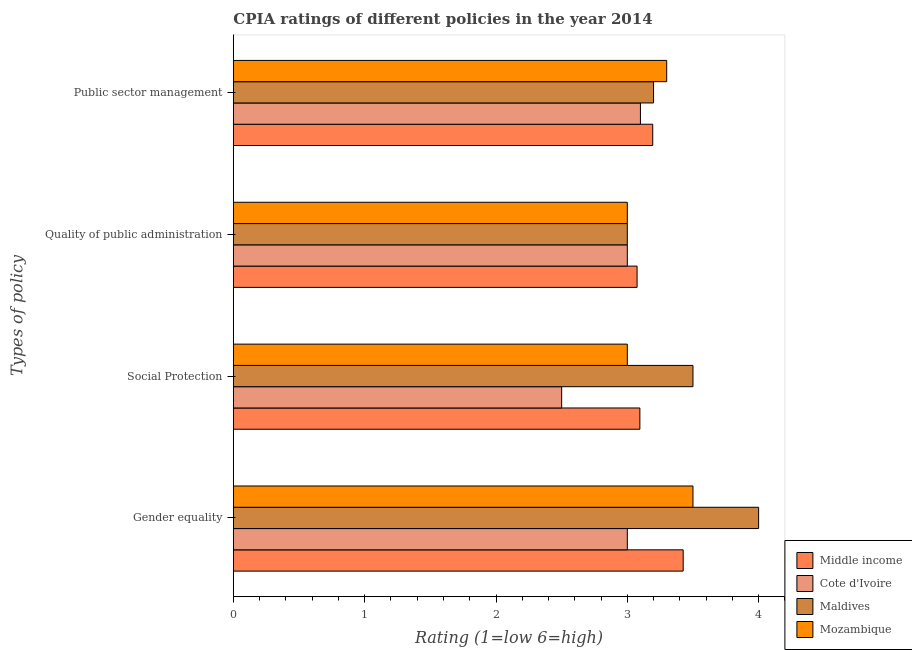How many different coloured bars are there?
Provide a succinct answer. 4. How many groups of bars are there?
Provide a succinct answer. 4. How many bars are there on the 1st tick from the top?
Your answer should be compact. 4. What is the label of the 3rd group of bars from the top?
Your answer should be compact. Social Protection. Across all countries, what is the minimum cpia rating of gender equality?
Keep it short and to the point. 3. In which country was the cpia rating of gender equality maximum?
Keep it short and to the point. Maldives. In which country was the cpia rating of social protection minimum?
Your response must be concise. Cote d'Ivoire. What is the total cpia rating of public sector management in the graph?
Offer a terse response. 12.79. What is the difference between the cpia rating of gender equality in Cote d'Ivoire and that in Maldives?
Your response must be concise. -1. What is the difference between the cpia rating of quality of public administration in Cote d'Ivoire and the cpia rating of public sector management in Maldives?
Offer a very short reply. -0.2. What is the average cpia rating of quality of public administration per country?
Offer a terse response. 3.02. What is the difference between the cpia rating of quality of public administration and cpia rating of social protection in Mozambique?
Your answer should be compact. 0. What is the ratio of the cpia rating of quality of public administration in Cote d'Ivoire to that in Middle income?
Provide a succinct answer. 0.98. What is the difference between the highest and the second highest cpia rating of quality of public administration?
Offer a very short reply. 0.07. What is the difference between the highest and the lowest cpia rating of social protection?
Keep it short and to the point. 1. What does the 2nd bar from the top in Public sector management represents?
Make the answer very short. Maldives. What does the 3rd bar from the bottom in Public sector management represents?
Your response must be concise. Maldives. How many countries are there in the graph?
Offer a terse response. 4. Does the graph contain grids?
Keep it short and to the point. No. What is the title of the graph?
Offer a terse response. CPIA ratings of different policies in the year 2014. Does "New Caledonia" appear as one of the legend labels in the graph?
Keep it short and to the point. No. What is the label or title of the X-axis?
Offer a very short reply. Rating (1=low 6=high). What is the label or title of the Y-axis?
Give a very brief answer. Types of policy. What is the Rating (1=low 6=high) in Middle income in Gender equality?
Provide a short and direct response. 3.43. What is the Rating (1=low 6=high) of Middle income in Social Protection?
Offer a terse response. 3.1. What is the Rating (1=low 6=high) of Maldives in Social Protection?
Your response must be concise. 3.5. What is the Rating (1=low 6=high) in Mozambique in Social Protection?
Give a very brief answer. 3. What is the Rating (1=low 6=high) in Middle income in Quality of public administration?
Make the answer very short. 3.07. What is the Rating (1=low 6=high) in Maldives in Quality of public administration?
Make the answer very short. 3. What is the Rating (1=low 6=high) of Mozambique in Quality of public administration?
Your response must be concise. 3. What is the Rating (1=low 6=high) in Middle income in Public sector management?
Ensure brevity in your answer.  3.19. What is the Rating (1=low 6=high) of Cote d'Ivoire in Public sector management?
Your answer should be compact. 3.1. What is the Rating (1=low 6=high) in Mozambique in Public sector management?
Make the answer very short. 3.3. Across all Types of policy, what is the maximum Rating (1=low 6=high) of Middle income?
Your answer should be compact. 3.43. Across all Types of policy, what is the maximum Rating (1=low 6=high) of Mozambique?
Offer a very short reply. 3.5. Across all Types of policy, what is the minimum Rating (1=low 6=high) of Middle income?
Ensure brevity in your answer.  3.07. Across all Types of policy, what is the minimum Rating (1=low 6=high) of Maldives?
Offer a terse response. 3. What is the total Rating (1=low 6=high) of Middle income in the graph?
Make the answer very short. 12.79. What is the total Rating (1=low 6=high) of Mozambique in the graph?
Provide a short and direct response. 12.8. What is the difference between the Rating (1=low 6=high) of Middle income in Gender equality and that in Social Protection?
Offer a terse response. 0.33. What is the difference between the Rating (1=low 6=high) of Cote d'Ivoire in Gender equality and that in Social Protection?
Provide a succinct answer. 0.5. What is the difference between the Rating (1=low 6=high) in Mozambique in Gender equality and that in Social Protection?
Your response must be concise. 0.5. What is the difference between the Rating (1=low 6=high) of Middle income in Gender equality and that in Quality of public administration?
Give a very brief answer. 0.35. What is the difference between the Rating (1=low 6=high) in Maldives in Gender equality and that in Quality of public administration?
Make the answer very short. 1. What is the difference between the Rating (1=low 6=high) in Middle income in Gender equality and that in Public sector management?
Offer a terse response. 0.23. What is the difference between the Rating (1=low 6=high) in Cote d'Ivoire in Gender equality and that in Public sector management?
Keep it short and to the point. -0.1. What is the difference between the Rating (1=low 6=high) of Middle income in Social Protection and that in Quality of public administration?
Give a very brief answer. 0.02. What is the difference between the Rating (1=low 6=high) in Mozambique in Social Protection and that in Quality of public administration?
Make the answer very short. 0. What is the difference between the Rating (1=low 6=high) of Middle income in Social Protection and that in Public sector management?
Your answer should be compact. -0.1. What is the difference between the Rating (1=low 6=high) in Cote d'Ivoire in Social Protection and that in Public sector management?
Provide a succinct answer. -0.6. What is the difference between the Rating (1=low 6=high) of Maldives in Social Protection and that in Public sector management?
Provide a short and direct response. 0.3. What is the difference between the Rating (1=low 6=high) of Mozambique in Social Protection and that in Public sector management?
Give a very brief answer. -0.3. What is the difference between the Rating (1=low 6=high) in Middle income in Quality of public administration and that in Public sector management?
Make the answer very short. -0.12. What is the difference between the Rating (1=low 6=high) in Cote d'Ivoire in Quality of public administration and that in Public sector management?
Offer a terse response. -0.1. What is the difference between the Rating (1=low 6=high) of Maldives in Quality of public administration and that in Public sector management?
Keep it short and to the point. -0.2. What is the difference between the Rating (1=low 6=high) of Mozambique in Quality of public administration and that in Public sector management?
Give a very brief answer. -0.3. What is the difference between the Rating (1=low 6=high) of Middle income in Gender equality and the Rating (1=low 6=high) of Cote d'Ivoire in Social Protection?
Make the answer very short. 0.93. What is the difference between the Rating (1=low 6=high) in Middle income in Gender equality and the Rating (1=low 6=high) in Maldives in Social Protection?
Make the answer very short. -0.07. What is the difference between the Rating (1=low 6=high) in Middle income in Gender equality and the Rating (1=low 6=high) in Mozambique in Social Protection?
Make the answer very short. 0.43. What is the difference between the Rating (1=low 6=high) of Cote d'Ivoire in Gender equality and the Rating (1=low 6=high) of Mozambique in Social Protection?
Keep it short and to the point. 0. What is the difference between the Rating (1=low 6=high) of Middle income in Gender equality and the Rating (1=low 6=high) of Cote d'Ivoire in Quality of public administration?
Your response must be concise. 0.43. What is the difference between the Rating (1=low 6=high) of Middle income in Gender equality and the Rating (1=low 6=high) of Maldives in Quality of public administration?
Give a very brief answer. 0.43. What is the difference between the Rating (1=low 6=high) in Middle income in Gender equality and the Rating (1=low 6=high) in Mozambique in Quality of public administration?
Offer a very short reply. 0.43. What is the difference between the Rating (1=low 6=high) in Cote d'Ivoire in Gender equality and the Rating (1=low 6=high) in Maldives in Quality of public administration?
Keep it short and to the point. 0. What is the difference between the Rating (1=low 6=high) of Cote d'Ivoire in Gender equality and the Rating (1=low 6=high) of Mozambique in Quality of public administration?
Offer a terse response. 0. What is the difference between the Rating (1=low 6=high) of Middle income in Gender equality and the Rating (1=low 6=high) of Cote d'Ivoire in Public sector management?
Your response must be concise. 0.33. What is the difference between the Rating (1=low 6=high) in Middle income in Gender equality and the Rating (1=low 6=high) in Maldives in Public sector management?
Your answer should be very brief. 0.23. What is the difference between the Rating (1=low 6=high) in Middle income in Gender equality and the Rating (1=low 6=high) in Mozambique in Public sector management?
Offer a very short reply. 0.13. What is the difference between the Rating (1=low 6=high) of Middle income in Social Protection and the Rating (1=low 6=high) of Cote d'Ivoire in Quality of public administration?
Make the answer very short. 0.1. What is the difference between the Rating (1=low 6=high) in Middle income in Social Protection and the Rating (1=low 6=high) in Maldives in Quality of public administration?
Make the answer very short. 0.1. What is the difference between the Rating (1=low 6=high) in Middle income in Social Protection and the Rating (1=low 6=high) in Mozambique in Quality of public administration?
Your answer should be very brief. 0.1. What is the difference between the Rating (1=low 6=high) of Cote d'Ivoire in Social Protection and the Rating (1=low 6=high) of Mozambique in Quality of public administration?
Keep it short and to the point. -0.5. What is the difference between the Rating (1=low 6=high) of Maldives in Social Protection and the Rating (1=low 6=high) of Mozambique in Quality of public administration?
Ensure brevity in your answer.  0.5. What is the difference between the Rating (1=low 6=high) in Middle income in Social Protection and the Rating (1=low 6=high) in Cote d'Ivoire in Public sector management?
Your answer should be very brief. -0. What is the difference between the Rating (1=low 6=high) of Middle income in Social Protection and the Rating (1=low 6=high) of Maldives in Public sector management?
Your answer should be compact. -0.1. What is the difference between the Rating (1=low 6=high) in Middle income in Social Protection and the Rating (1=low 6=high) in Mozambique in Public sector management?
Offer a very short reply. -0.2. What is the difference between the Rating (1=low 6=high) in Cote d'Ivoire in Social Protection and the Rating (1=low 6=high) in Maldives in Public sector management?
Offer a very short reply. -0.7. What is the difference between the Rating (1=low 6=high) in Maldives in Social Protection and the Rating (1=low 6=high) in Mozambique in Public sector management?
Your answer should be very brief. 0.2. What is the difference between the Rating (1=low 6=high) in Middle income in Quality of public administration and the Rating (1=low 6=high) in Cote d'Ivoire in Public sector management?
Keep it short and to the point. -0.03. What is the difference between the Rating (1=low 6=high) in Middle income in Quality of public administration and the Rating (1=low 6=high) in Maldives in Public sector management?
Provide a short and direct response. -0.13. What is the difference between the Rating (1=low 6=high) in Middle income in Quality of public administration and the Rating (1=low 6=high) in Mozambique in Public sector management?
Your answer should be compact. -0.23. What is the difference between the Rating (1=low 6=high) in Cote d'Ivoire in Quality of public administration and the Rating (1=low 6=high) in Maldives in Public sector management?
Ensure brevity in your answer.  -0.2. What is the difference between the Rating (1=low 6=high) of Maldives in Quality of public administration and the Rating (1=low 6=high) of Mozambique in Public sector management?
Offer a terse response. -0.3. What is the average Rating (1=low 6=high) of Middle income per Types of policy?
Offer a terse response. 3.2. What is the average Rating (1=low 6=high) in Maldives per Types of policy?
Your answer should be compact. 3.42. What is the difference between the Rating (1=low 6=high) in Middle income and Rating (1=low 6=high) in Cote d'Ivoire in Gender equality?
Your answer should be compact. 0.43. What is the difference between the Rating (1=low 6=high) in Middle income and Rating (1=low 6=high) in Maldives in Gender equality?
Keep it short and to the point. -0.57. What is the difference between the Rating (1=low 6=high) of Middle income and Rating (1=low 6=high) of Mozambique in Gender equality?
Offer a very short reply. -0.07. What is the difference between the Rating (1=low 6=high) of Cote d'Ivoire and Rating (1=low 6=high) of Maldives in Gender equality?
Give a very brief answer. -1. What is the difference between the Rating (1=low 6=high) of Cote d'Ivoire and Rating (1=low 6=high) of Mozambique in Gender equality?
Your answer should be very brief. -0.5. What is the difference between the Rating (1=low 6=high) of Maldives and Rating (1=low 6=high) of Mozambique in Gender equality?
Give a very brief answer. 0.5. What is the difference between the Rating (1=low 6=high) of Middle income and Rating (1=low 6=high) of Cote d'Ivoire in Social Protection?
Offer a very short reply. 0.6. What is the difference between the Rating (1=low 6=high) in Middle income and Rating (1=low 6=high) in Maldives in Social Protection?
Offer a very short reply. -0.4. What is the difference between the Rating (1=low 6=high) in Middle income and Rating (1=low 6=high) in Mozambique in Social Protection?
Offer a very short reply. 0.1. What is the difference between the Rating (1=low 6=high) in Cote d'Ivoire and Rating (1=low 6=high) in Maldives in Social Protection?
Your answer should be very brief. -1. What is the difference between the Rating (1=low 6=high) of Cote d'Ivoire and Rating (1=low 6=high) of Mozambique in Social Protection?
Offer a very short reply. -0.5. What is the difference between the Rating (1=low 6=high) of Maldives and Rating (1=low 6=high) of Mozambique in Social Protection?
Your answer should be compact. 0.5. What is the difference between the Rating (1=low 6=high) in Middle income and Rating (1=low 6=high) in Cote d'Ivoire in Quality of public administration?
Offer a terse response. 0.07. What is the difference between the Rating (1=low 6=high) of Middle income and Rating (1=low 6=high) of Maldives in Quality of public administration?
Keep it short and to the point. 0.07. What is the difference between the Rating (1=low 6=high) in Middle income and Rating (1=low 6=high) in Mozambique in Quality of public administration?
Your answer should be very brief. 0.07. What is the difference between the Rating (1=low 6=high) of Cote d'Ivoire and Rating (1=low 6=high) of Maldives in Quality of public administration?
Your response must be concise. 0. What is the difference between the Rating (1=low 6=high) in Maldives and Rating (1=low 6=high) in Mozambique in Quality of public administration?
Your response must be concise. 0. What is the difference between the Rating (1=low 6=high) of Middle income and Rating (1=low 6=high) of Cote d'Ivoire in Public sector management?
Make the answer very short. 0.09. What is the difference between the Rating (1=low 6=high) of Middle income and Rating (1=low 6=high) of Maldives in Public sector management?
Keep it short and to the point. -0.01. What is the difference between the Rating (1=low 6=high) of Middle income and Rating (1=low 6=high) of Mozambique in Public sector management?
Ensure brevity in your answer.  -0.11. What is the difference between the Rating (1=low 6=high) of Cote d'Ivoire and Rating (1=low 6=high) of Maldives in Public sector management?
Your response must be concise. -0.1. What is the difference between the Rating (1=low 6=high) of Cote d'Ivoire and Rating (1=low 6=high) of Mozambique in Public sector management?
Make the answer very short. -0.2. What is the ratio of the Rating (1=low 6=high) in Middle income in Gender equality to that in Social Protection?
Ensure brevity in your answer.  1.11. What is the ratio of the Rating (1=low 6=high) in Cote d'Ivoire in Gender equality to that in Social Protection?
Make the answer very short. 1.2. What is the ratio of the Rating (1=low 6=high) of Maldives in Gender equality to that in Social Protection?
Your answer should be compact. 1.14. What is the ratio of the Rating (1=low 6=high) of Mozambique in Gender equality to that in Social Protection?
Your answer should be very brief. 1.17. What is the ratio of the Rating (1=low 6=high) in Middle income in Gender equality to that in Quality of public administration?
Your answer should be compact. 1.11. What is the ratio of the Rating (1=low 6=high) of Cote d'Ivoire in Gender equality to that in Quality of public administration?
Provide a succinct answer. 1. What is the ratio of the Rating (1=low 6=high) in Maldives in Gender equality to that in Quality of public administration?
Provide a short and direct response. 1.33. What is the ratio of the Rating (1=low 6=high) in Mozambique in Gender equality to that in Quality of public administration?
Offer a terse response. 1.17. What is the ratio of the Rating (1=low 6=high) of Middle income in Gender equality to that in Public sector management?
Your response must be concise. 1.07. What is the ratio of the Rating (1=low 6=high) of Maldives in Gender equality to that in Public sector management?
Provide a short and direct response. 1.25. What is the ratio of the Rating (1=low 6=high) in Mozambique in Gender equality to that in Public sector management?
Ensure brevity in your answer.  1.06. What is the ratio of the Rating (1=low 6=high) of Middle income in Social Protection to that in Quality of public administration?
Your response must be concise. 1.01. What is the ratio of the Rating (1=low 6=high) of Maldives in Social Protection to that in Quality of public administration?
Offer a very short reply. 1.17. What is the ratio of the Rating (1=low 6=high) of Mozambique in Social Protection to that in Quality of public administration?
Ensure brevity in your answer.  1. What is the ratio of the Rating (1=low 6=high) of Middle income in Social Protection to that in Public sector management?
Keep it short and to the point. 0.97. What is the ratio of the Rating (1=low 6=high) in Cote d'Ivoire in Social Protection to that in Public sector management?
Provide a succinct answer. 0.81. What is the ratio of the Rating (1=low 6=high) in Maldives in Social Protection to that in Public sector management?
Offer a very short reply. 1.09. What is the ratio of the Rating (1=low 6=high) of Mozambique in Social Protection to that in Public sector management?
Ensure brevity in your answer.  0.91. What is the ratio of the Rating (1=low 6=high) of Middle income in Quality of public administration to that in Public sector management?
Offer a terse response. 0.96. What is the ratio of the Rating (1=low 6=high) in Cote d'Ivoire in Quality of public administration to that in Public sector management?
Offer a very short reply. 0.97. What is the ratio of the Rating (1=low 6=high) of Mozambique in Quality of public administration to that in Public sector management?
Your answer should be compact. 0.91. What is the difference between the highest and the second highest Rating (1=low 6=high) in Middle income?
Ensure brevity in your answer.  0.23. What is the difference between the highest and the second highest Rating (1=low 6=high) in Maldives?
Provide a short and direct response. 0.5. What is the difference between the highest and the second highest Rating (1=low 6=high) of Mozambique?
Your answer should be very brief. 0.2. What is the difference between the highest and the lowest Rating (1=low 6=high) in Middle income?
Offer a terse response. 0.35. 